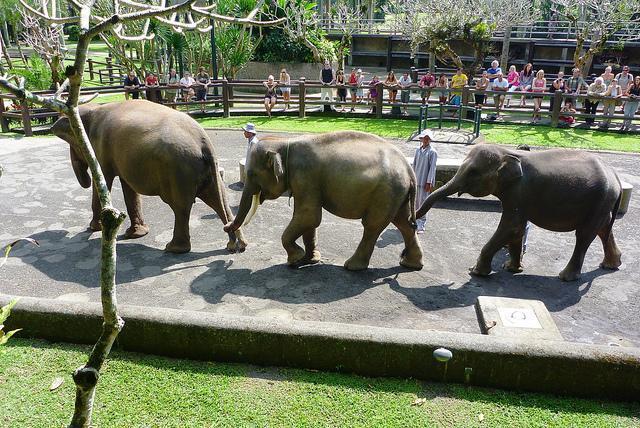What direction are the elephants marching?
Indicate the correct response by choosing from the four available options to answer the question.
Options: West, east, north, south. West. 